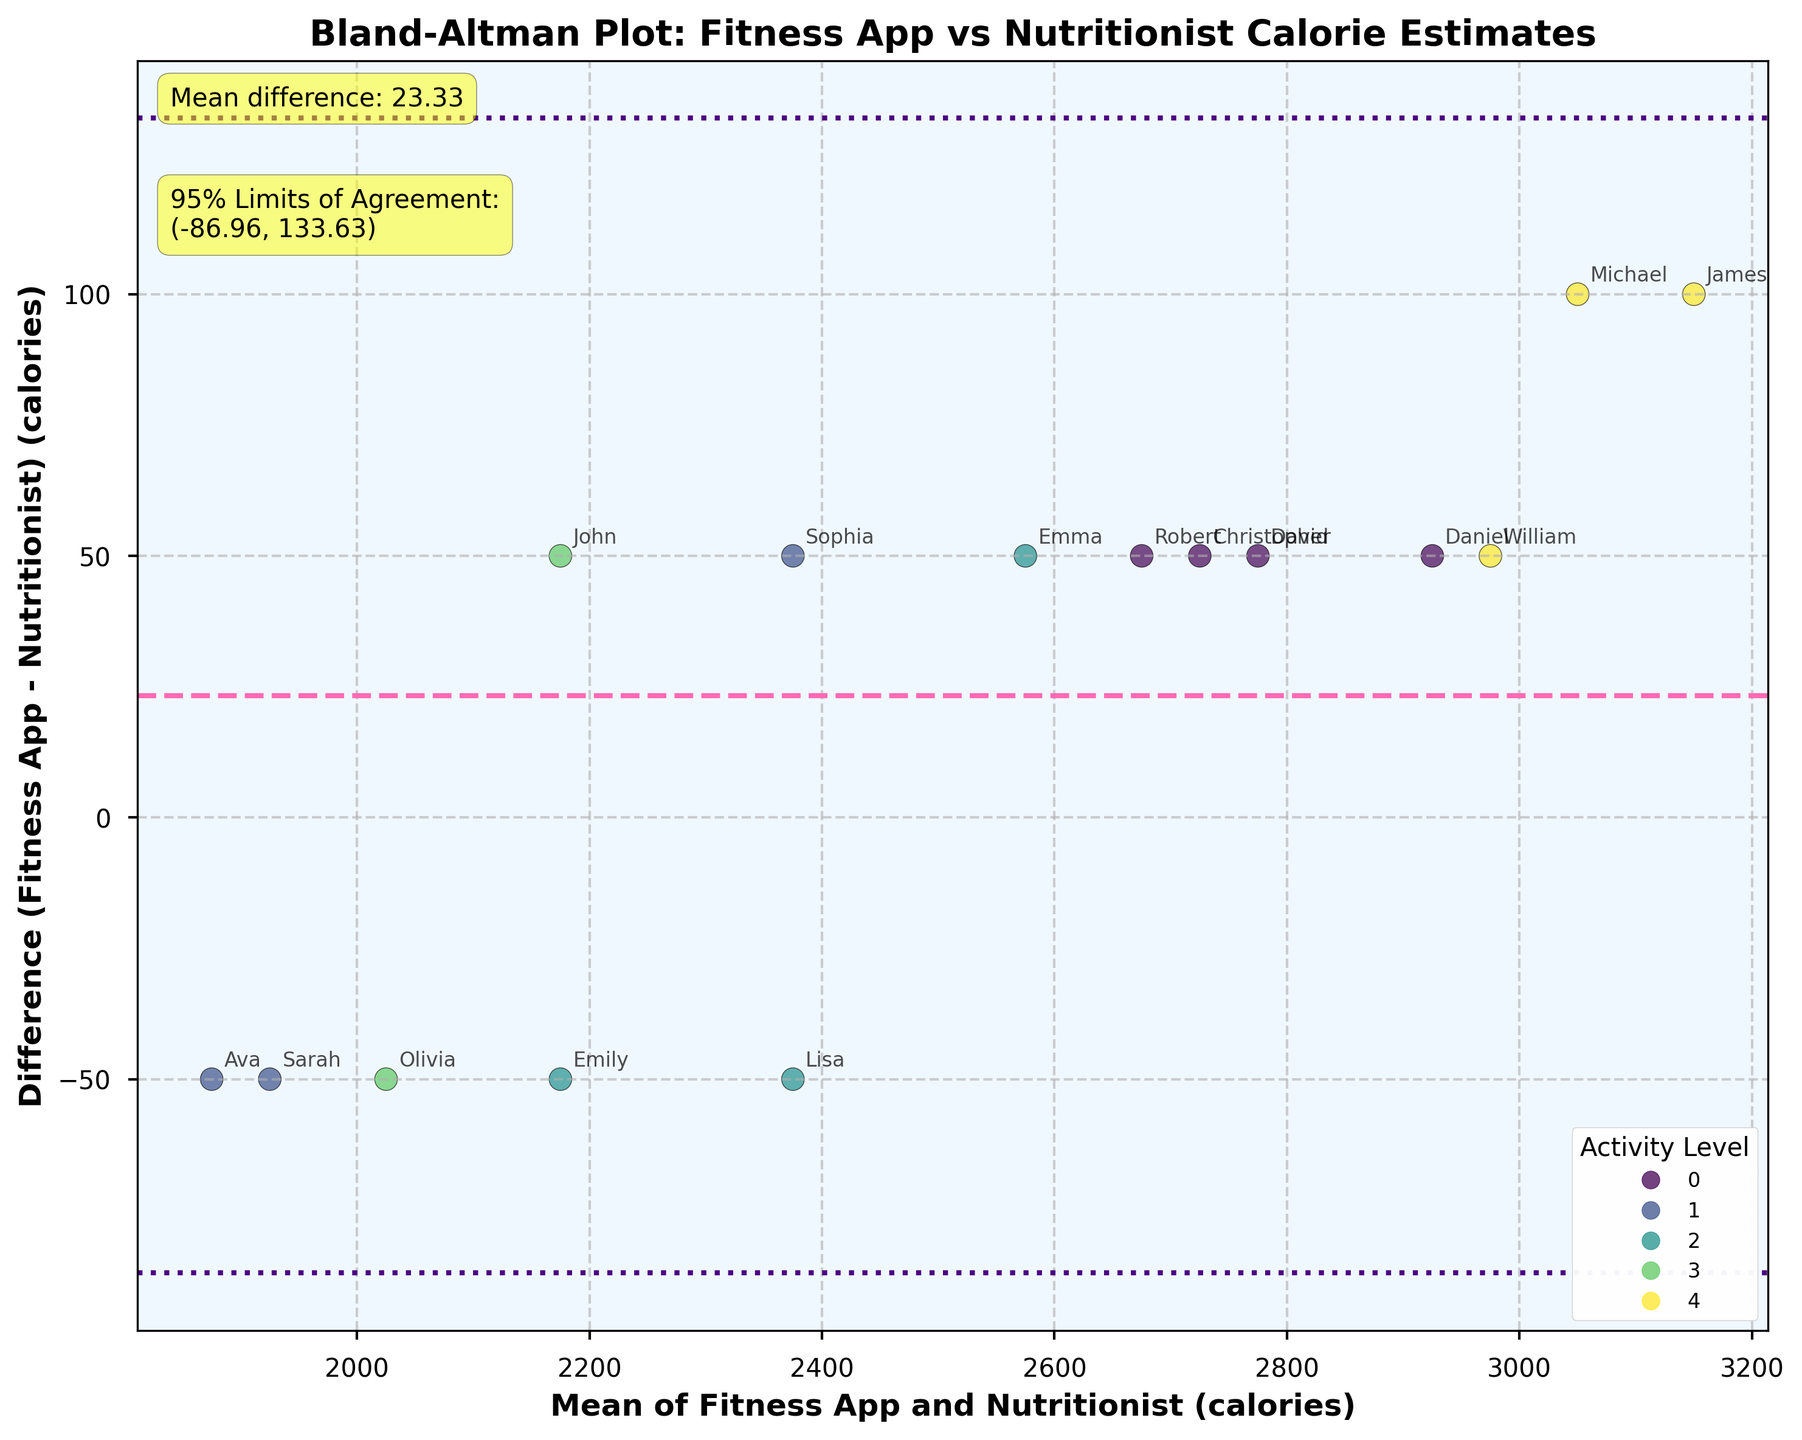What is the title of the plot? The title is positioned at the top of the plot, indicating the main subject of the visualization.
Answer: Bland-Altman Plot: Fitness App vs Nutritionist Calorie Estimates What are the axes labels? The x-axis and y-axis have labels that describe the variables being plotted. The x-axis represents the mean calorie intake between the Fitness App and the Nutritionist, and the y-axis shows the difference (Fitness App - Nutritionist).
Answer: x-axis: Mean of Fitness App and Nutritionist (calories); y-axis: Difference (Fitness App - Nutritionist) (calories) What is the mean difference between the Fitness App and Nutritionist calorie estimates? The mean difference is explicitly annotated on the plot near the top-left corner.
Answer: 20.00 What are the limits of agreement for the calorie estimates? The limits of agreement are annotated on the plot near the top-left corner, underneath the mean difference annotation.
Answer: (-24.72, 64.72) How many activity levels are represented in the plot, and what colors represent them? The plot's legend shows the different activity levels along with the corresponding colors used in the scatter plot.
Answer: 5 activity levels: Sedentary (yellow), Lightly Active (light green), Moderately Active (green), Active (dark green), Very Active (blue) Which subject has the highest mean calorie intake between the Fitness App and Nutritionist? To find the highest mean, look for the furthest right data point on the x-axis. The annotated name next to this point represents the subject.
Answer: James Are there any subjects whose Fitness App calorie estimate is exactly the same as the Nutritionist's estimate? Look for any points on the plot where the difference (y-axis value) is 0, which means the estimates are equal.
Answer: No What is the difference in calories for the subject with the lowest mean intake? Identify the leftmost point on the x-axis and note its y-axis value, which represents the difference. The subject's name is also annotated next to this point.
Answer: Sarah, -50 Which activity level shows the most scattered differences in calorie intake estimates? Observe which color-coded group has the widest spread along the y-axis. This color relates to a specific activity level noted in the legend.
Answer: Active (dark green) Comparing Sarah and Ava, who has a more consistent estimate between the Fitness App and Nutritionist, and by how much? Compare their differences noted on the y-axis. Ava’s difference is between the two horizontal lines denoting limits of agreement. Sarah's difference is at -50; Ava's is at -50. The difference in consistency is zero in terms of actual value, though both subjects have discrepancies.
Answer: Ava and Sarah both have -50, equally consistent or inconsistent 